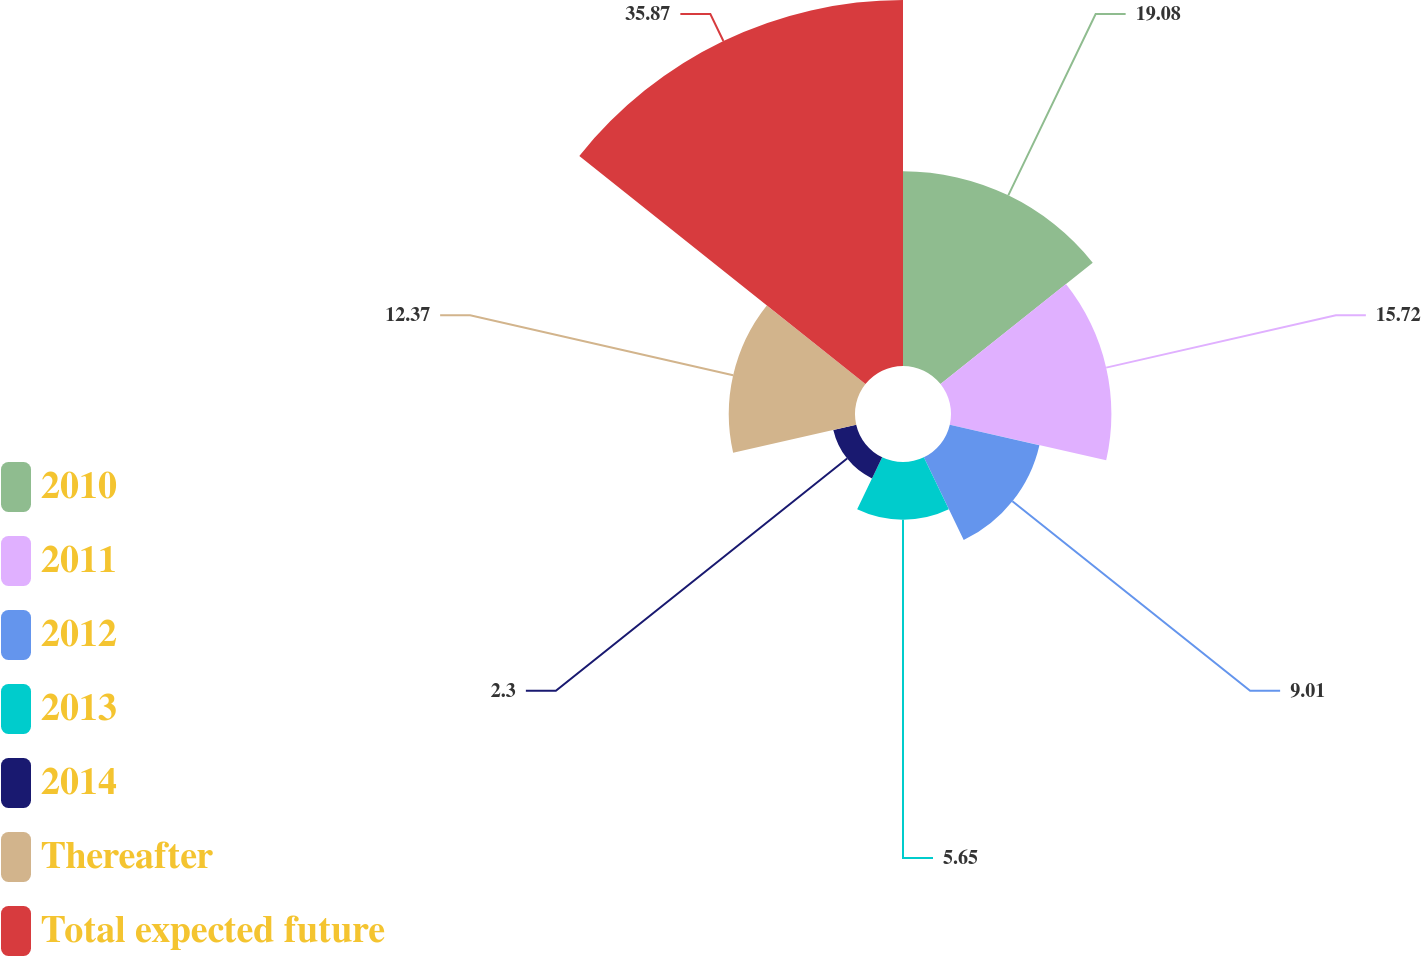Convert chart to OTSL. <chart><loc_0><loc_0><loc_500><loc_500><pie_chart><fcel>2010<fcel>2011<fcel>2012<fcel>2013<fcel>2014<fcel>Thereafter<fcel>Total expected future<nl><fcel>19.08%<fcel>15.72%<fcel>9.01%<fcel>5.65%<fcel>2.3%<fcel>12.37%<fcel>35.87%<nl></chart> 